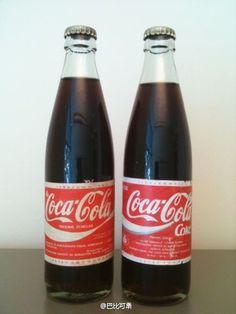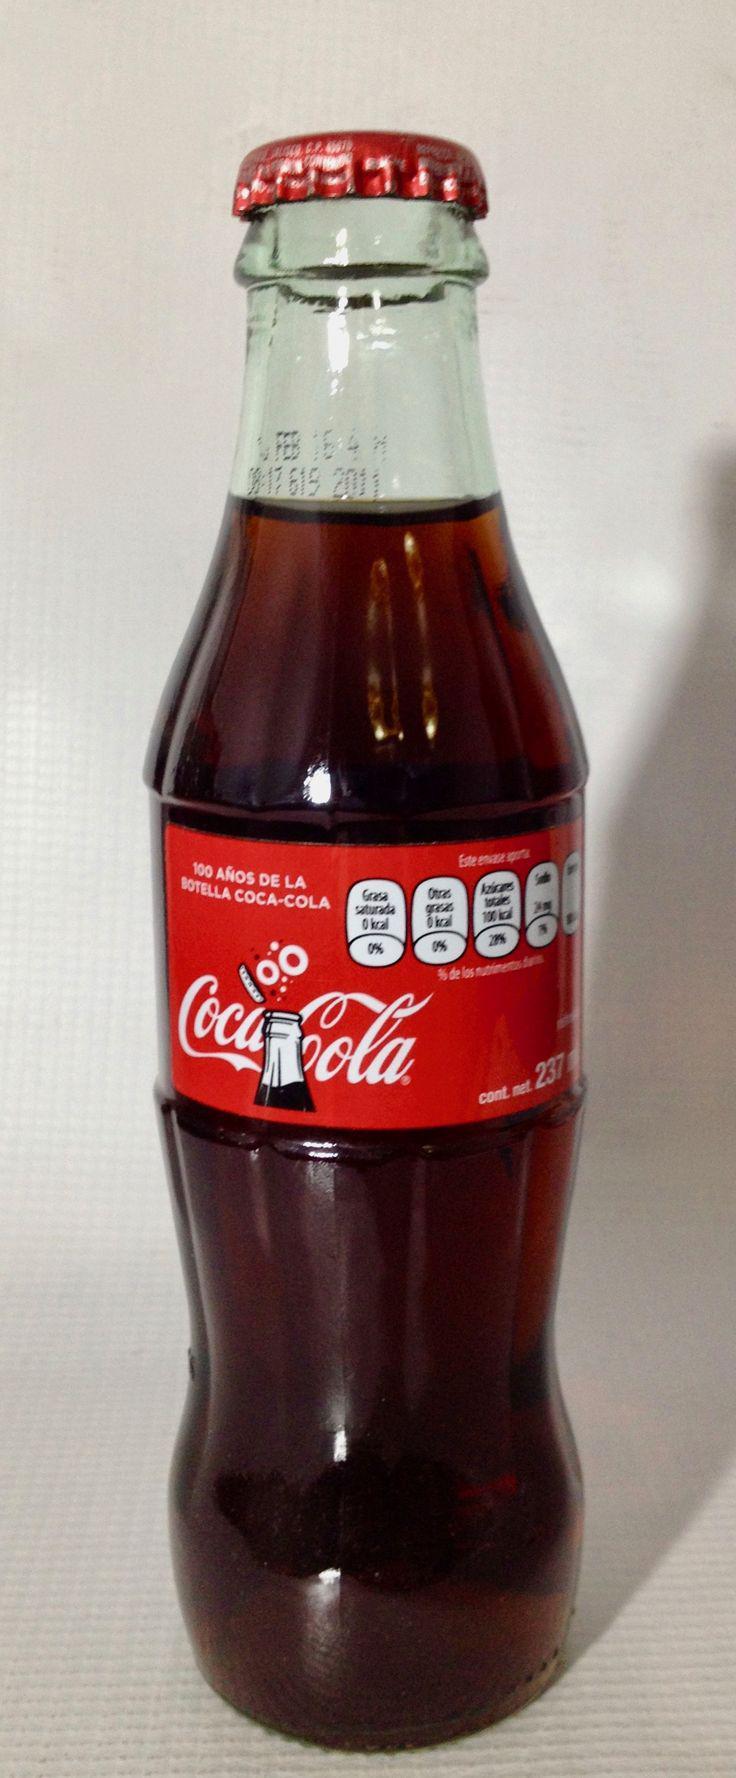The first image is the image on the left, the second image is the image on the right. For the images shown, is this caption "There are two bottles in the image on the left and half that in the image on the right." true? Answer yes or no. Yes. The first image is the image on the left, the second image is the image on the right. For the images shown, is this caption "All the bottles are filled with a dark liquid." true? Answer yes or no. Yes. 